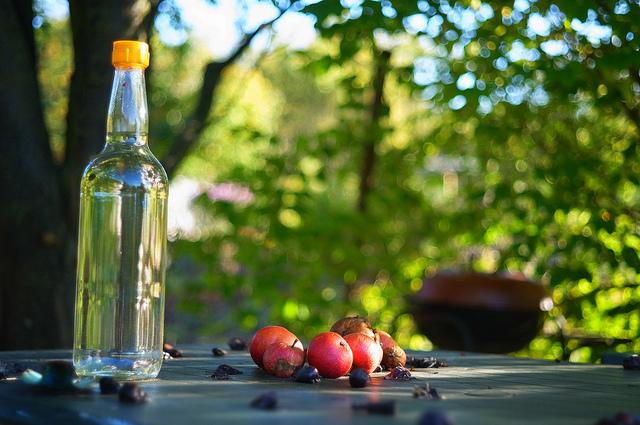What sort of vinegar can be made with these red things?
Short answer required. Apple cider. What fruit is on table?
Concise answer only. Apple. Does this bottle need a refill?
Keep it brief. Yes. 